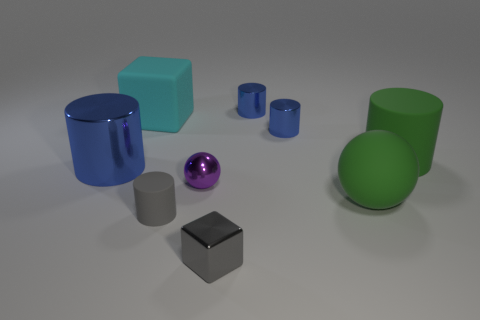Do the gray object behind the tiny gray metallic thing and the blue cylinder left of the tiny purple shiny ball have the same material?
Provide a succinct answer. No. There is a sphere that is behind the green rubber object that is on the left side of the green rubber cylinder; how big is it?
Make the answer very short. Small. What material is the object that is behind the cyan block?
Keep it short and to the point. Metal. What number of things are blue metal cylinders that are behind the cyan rubber thing or things that are in front of the big cyan matte object?
Your answer should be very brief. 8. What is the material of the big green object that is the same shape as the tiny purple shiny thing?
Your response must be concise. Rubber. There is a large thing behind the green matte cylinder; does it have the same color as the large thing in front of the purple metal sphere?
Your response must be concise. No. Are there any metallic blocks of the same size as the gray rubber thing?
Provide a short and direct response. Yes. There is a tiny cylinder that is both in front of the cyan object and right of the small gray metal block; what is its material?
Keep it short and to the point. Metal. What number of matte things are either large blue things or tiny brown cubes?
Provide a succinct answer. 0. What shape is the big cyan object that is the same material as the small gray cylinder?
Offer a very short reply. Cube. 